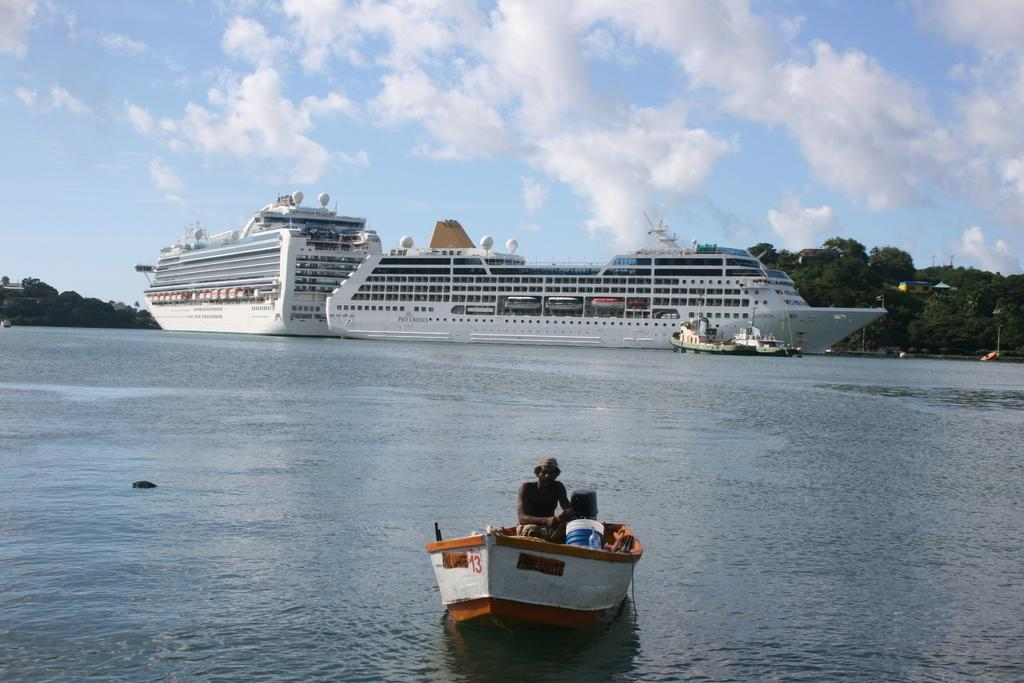What is the main subject of the image? There is a person in the image. Where is the person located in the image? The person is in a boat. What is the boat situated on? The boat is on the water. What can be seen in the background of the image? There are ships, poles, trees, buildings, and objects in the background of the image. There are also clouds in the sky. What type of bells can be heard ringing in the image? There are no bells present in the image, and therefore no sound can be heard. 